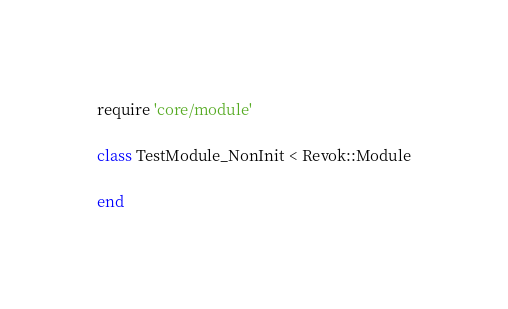<code> <loc_0><loc_0><loc_500><loc_500><_Ruby_>require 'core/module' 

class TestModule_NonInit < Revok::Module

end
</code> 